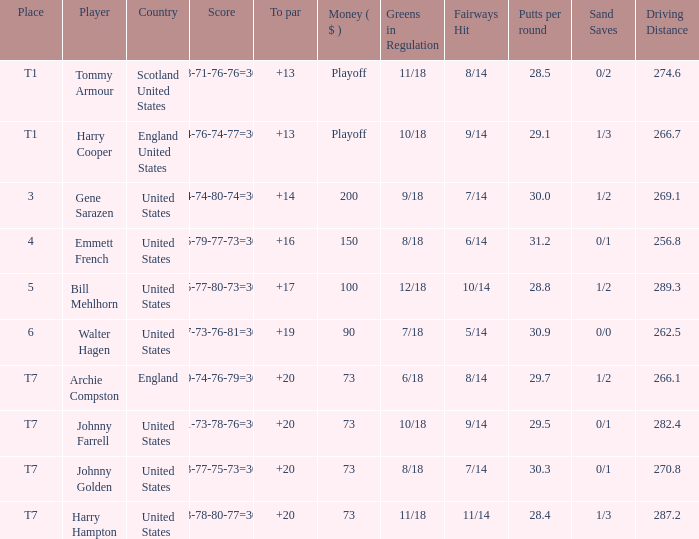Which country has a to par less than 19 and a score of 75-79-77-73=304? United States. 